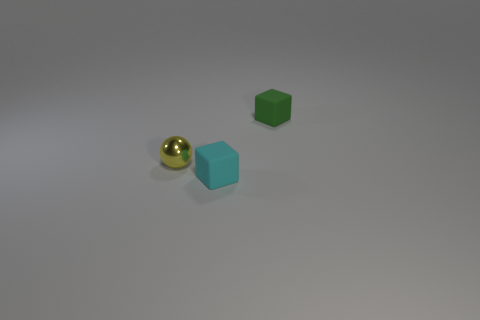Add 3 tiny metallic balls. How many objects exist? 6 Subtract all blocks. How many objects are left? 1 Add 2 cyan rubber objects. How many cyan rubber objects exist? 3 Subtract 0 gray cubes. How many objects are left? 3 Subtract all big purple cubes. Subtract all yellow spheres. How many objects are left? 2 Add 2 tiny metal things. How many tiny metal things are left? 3 